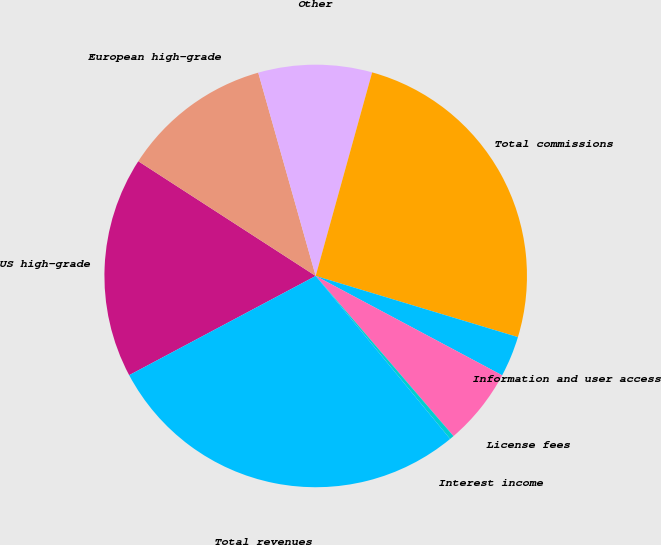Convert chart. <chart><loc_0><loc_0><loc_500><loc_500><pie_chart><fcel>US high-grade<fcel>European high-grade<fcel>Other<fcel>Total commissions<fcel>Information and user access<fcel>License fees<fcel>Interest income<fcel>Total revenues<nl><fcel>16.92%<fcel>11.48%<fcel>8.69%<fcel>25.37%<fcel>3.12%<fcel>5.9%<fcel>0.33%<fcel>28.2%<nl></chart> 